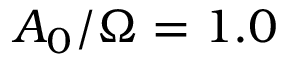<formula> <loc_0><loc_0><loc_500><loc_500>A _ { 0 } / \Omega = 1 . 0</formula> 